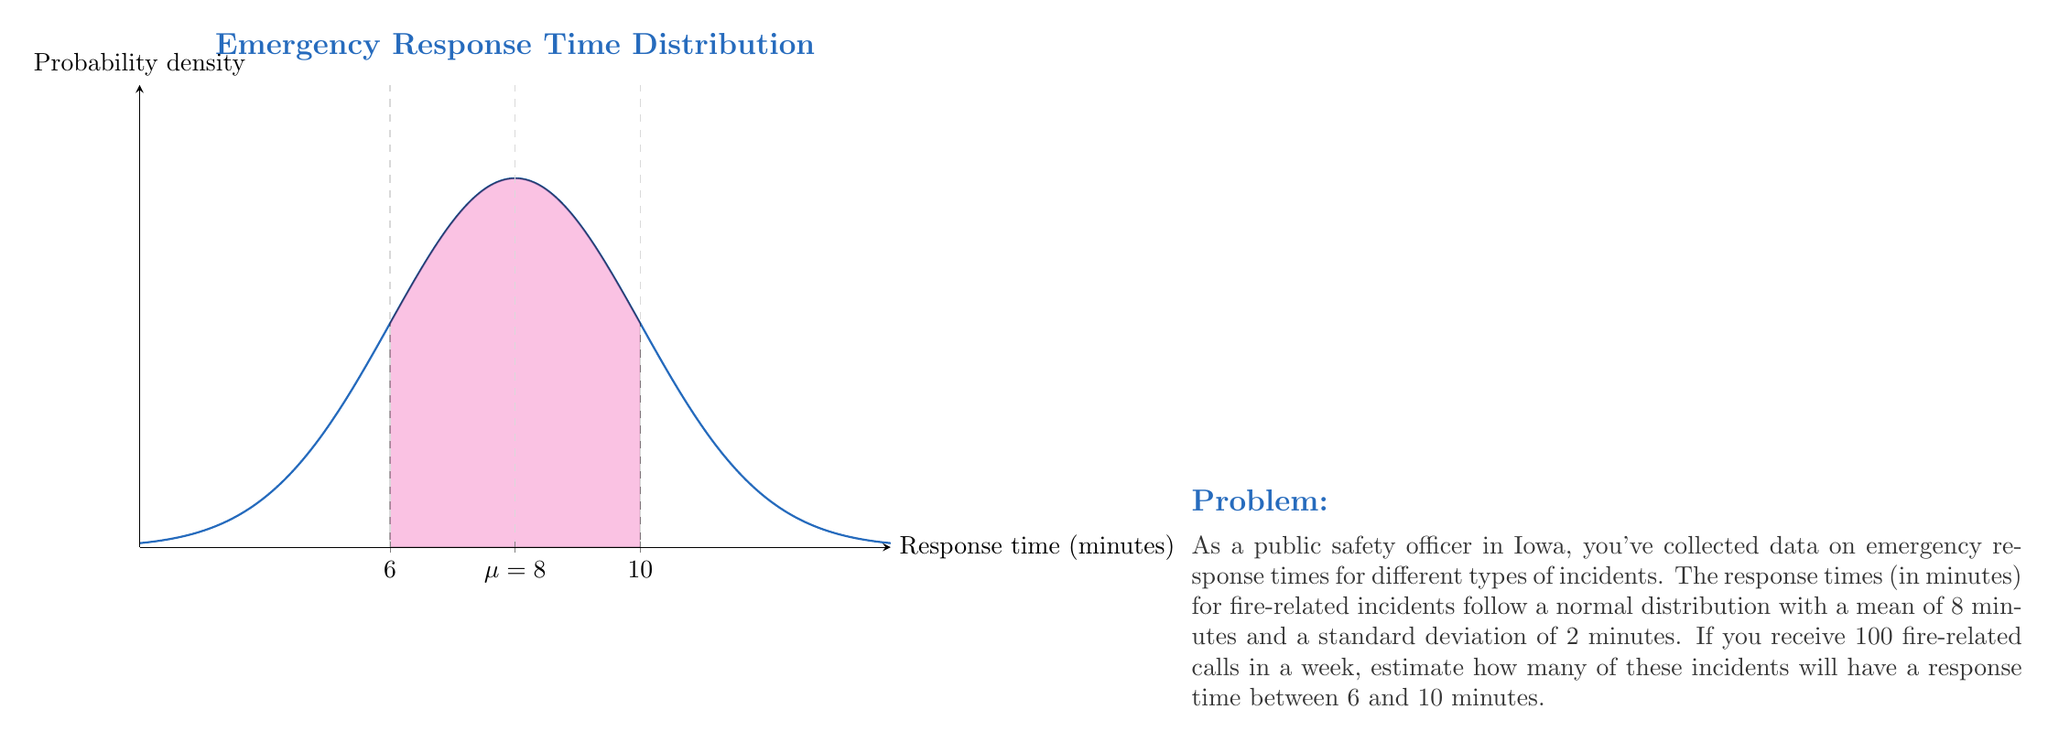Solve this math problem. Let's approach this step-by-step:

1) The response times follow a normal distribution with $\mu = 8$ and $\sigma = 2$.

2) We need to find the probability of a response time between 6 and 10 minutes.

3) First, let's standardize these values:
   For 6 minutes: $z_1 = \frac{6 - 8}{2} = -1$
   For 10 minutes: $z_2 = \frac{10 - 8}{2} = 1$

4) Now, we need to find $P(-1 < Z < 1)$, where $Z$ is the standard normal variable.

5) Using the standard normal table or a calculator:
   $P(Z < 1) = 0.8413$
   $P(Z < -1) = 0.1587$

6) Therefore, $P(-1 < Z < 1) = 0.8413 - 0.1587 = 0.6826$

7) This means that 68.26% of the response times will be between 6 and 10 minutes.

8) If there are 100 calls in a week, the expected number of calls with response times between 6 and 10 minutes is:

   $100 \times 0.6826 = 68.26$

9) Since we can't have a fractional number of calls, we round to the nearest whole number: 68.
Answer: 68 incidents 